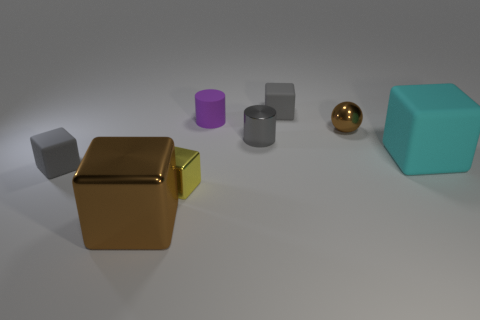Subtract all cyan matte blocks. How many blocks are left? 4 Subtract all yellow cubes. How many cubes are left? 4 Subtract all purple cubes. Subtract all gray cylinders. How many cubes are left? 5 Add 2 cyan cubes. How many objects exist? 10 Subtract all balls. How many objects are left? 7 Add 6 red metal blocks. How many red metal blocks exist? 6 Subtract 0 brown cylinders. How many objects are left? 8 Subtract all big cyan rubber cubes. Subtract all large matte cubes. How many objects are left? 6 Add 2 tiny metallic cylinders. How many tiny metallic cylinders are left? 3 